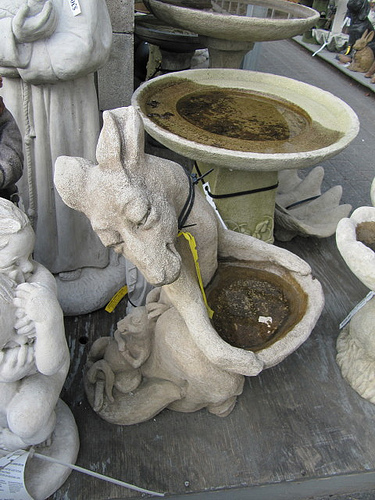<image>
Is the water next to the statue? No. The water is not positioned next to the statue. They are located in different areas of the scene. 